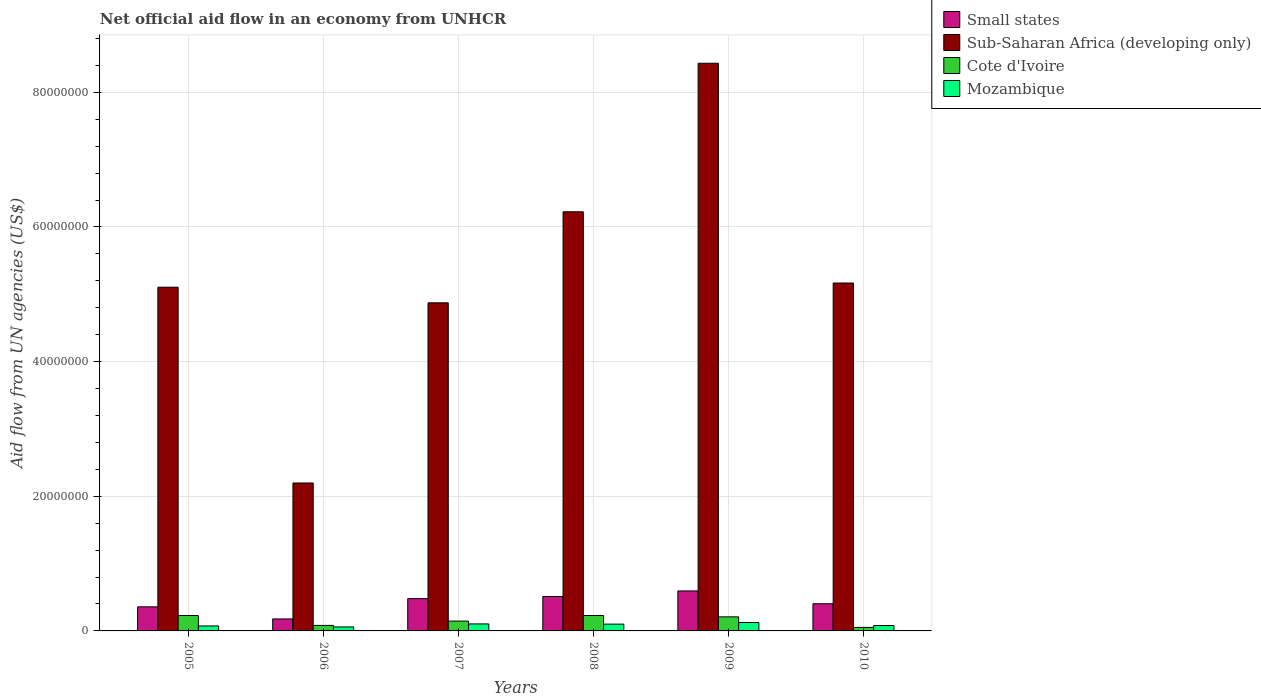How many different coloured bars are there?
Provide a succinct answer. 4. Are the number of bars per tick equal to the number of legend labels?
Make the answer very short. Yes. How many bars are there on the 1st tick from the right?
Provide a succinct answer. 4. What is the label of the 1st group of bars from the left?
Give a very brief answer. 2005. What is the net official aid flow in Small states in 2006?
Give a very brief answer. 1.78e+06. Across all years, what is the maximum net official aid flow in Mozambique?
Provide a short and direct response. 1.25e+06. Across all years, what is the minimum net official aid flow in Small states?
Your response must be concise. 1.78e+06. In which year was the net official aid flow in Cote d'Ivoire minimum?
Make the answer very short. 2010. What is the total net official aid flow in Mozambique in the graph?
Give a very brief answer. 5.43e+06. What is the difference between the net official aid flow in Small states in 2009 and that in 2010?
Your answer should be very brief. 1.90e+06. What is the difference between the net official aid flow in Mozambique in 2009 and the net official aid flow in Sub-Saharan Africa (developing only) in 2006?
Provide a succinct answer. -2.07e+07. What is the average net official aid flow in Sub-Saharan Africa (developing only) per year?
Keep it short and to the point. 5.33e+07. In the year 2007, what is the difference between the net official aid flow in Small states and net official aid flow in Cote d'Ivoire?
Your answer should be compact. 3.34e+06. In how many years, is the net official aid flow in Mozambique greater than 68000000 US$?
Provide a succinct answer. 0. Is the difference between the net official aid flow in Small states in 2006 and 2008 greater than the difference between the net official aid flow in Cote d'Ivoire in 2006 and 2008?
Make the answer very short. No. What is the difference between the highest and the second highest net official aid flow in Small states?
Give a very brief answer. 8.30e+05. What is the difference between the highest and the lowest net official aid flow in Small states?
Keep it short and to the point. 4.16e+06. Is it the case that in every year, the sum of the net official aid flow in Cote d'Ivoire and net official aid flow in Mozambique is greater than the sum of net official aid flow in Small states and net official aid flow in Sub-Saharan Africa (developing only)?
Make the answer very short. No. What does the 3rd bar from the left in 2005 represents?
Give a very brief answer. Cote d'Ivoire. What does the 4th bar from the right in 2009 represents?
Your response must be concise. Small states. Is it the case that in every year, the sum of the net official aid flow in Small states and net official aid flow in Sub-Saharan Africa (developing only) is greater than the net official aid flow in Cote d'Ivoire?
Your answer should be very brief. Yes. Does the graph contain any zero values?
Offer a terse response. No. Does the graph contain grids?
Offer a terse response. Yes. Where does the legend appear in the graph?
Give a very brief answer. Top right. How are the legend labels stacked?
Ensure brevity in your answer.  Vertical. What is the title of the graph?
Make the answer very short. Net official aid flow in an economy from UNHCR. Does "Other small states" appear as one of the legend labels in the graph?
Your answer should be very brief. No. What is the label or title of the X-axis?
Your answer should be compact. Years. What is the label or title of the Y-axis?
Provide a short and direct response. Aid flow from UN agencies (US$). What is the Aid flow from UN agencies (US$) of Small states in 2005?
Keep it short and to the point. 3.58e+06. What is the Aid flow from UN agencies (US$) in Sub-Saharan Africa (developing only) in 2005?
Provide a succinct answer. 5.10e+07. What is the Aid flow from UN agencies (US$) in Cote d'Ivoire in 2005?
Ensure brevity in your answer.  2.29e+06. What is the Aid flow from UN agencies (US$) of Mozambique in 2005?
Give a very brief answer. 7.40e+05. What is the Aid flow from UN agencies (US$) in Small states in 2006?
Offer a very short reply. 1.78e+06. What is the Aid flow from UN agencies (US$) of Sub-Saharan Africa (developing only) in 2006?
Make the answer very short. 2.20e+07. What is the Aid flow from UN agencies (US$) in Cote d'Ivoire in 2006?
Provide a short and direct response. 8.20e+05. What is the Aid flow from UN agencies (US$) of Mozambique in 2006?
Make the answer very short. 5.90e+05. What is the Aid flow from UN agencies (US$) of Small states in 2007?
Offer a very short reply. 4.80e+06. What is the Aid flow from UN agencies (US$) of Sub-Saharan Africa (developing only) in 2007?
Ensure brevity in your answer.  4.87e+07. What is the Aid flow from UN agencies (US$) of Cote d'Ivoire in 2007?
Give a very brief answer. 1.46e+06. What is the Aid flow from UN agencies (US$) of Mozambique in 2007?
Keep it short and to the point. 1.04e+06. What is the Aid flow from UN agencies (US$) of Small states in 2008?
Give a very brief answer. 5.11e+06. What is the Aid flow from UN agencies (US$) of Sub-Saharan Africa (developing only) in 2008?
Offer a terse response. 6.22e+07. What is the Aid flow from UN agencies (US$) of Cote d'Ivoire in 2008?
Provide a succinct answer. 2.29e+06. What is the Aid flow from UN agencies (US$) of Mozambique in 2008?
Offer a very short reply. 1.01e+06. What is the Aid flow from UN agencies (US$) in Small states in 2009?
Your response must be concise. 5.94e+06. What is the Aid flow from UN agencies (US$) of Sub-Saharan Africa (developing only) in 2009?
Offer a very short reply. 8.43e+07. What is the Aid flow from UN agencies (US$) in Cote d'Ivoire in 2009?
Your answer should be compact. 2.09e+06. What is the Aid flow from UN agencies (US$) in Mozambique in 2009?
Your response must be concise. 1.25e+06. What is the Aid flow from UN agencies (US$) of Small states in 2010?
Give a very brief answer. 4.04e+06. What is the Aid flow from UN agencies (US$) in Sub-Saharan Africa (developing only) in 2010?
Offer a very short reply. 5.17e+07. What is the Aid flow from UN agencies (US$) in Cote d'Ivoire in 2010?
Provide a succinct answer. 5.20e+05. Across all years, what is the maximum Aid flow from UN agencies (US$) in Small states?
Offer a very short reply. 5.94e+06. Across all years, what is the maximum Aid flow from UN agencies (US$) of Sub-Saharan Africa (developing only)?
Keep it short and to the point. 8.43e+07. Across all years, what is the maximum Aid flow from UN agencies (US$) of Cote d'Ivoire?
Provide a succinct answer. 2.29e+06. Across all years, what is the maximum Aid flow from UN agencies (US$) of Mozambique?
Ensure brevity in your answer.  1.25e+06. Across all years, what is the minimum Aid flow from UN agencies (US$) in Small states?
Your answer should be very brief. 1.78e+06. Across all years, what is the minimum Aid flow from UN agencies (US$) in Sub-Saharan Africa (developing only)?
Provide a succinct answer. 2.20e+07. Across all years, what is the minimum Aid flow from UN agencies (US$) of Cote d'Ivoire?
Offer a terse response. 5.20e+05. Across all years, what is the minimum Aid flow from UN agencies (US$) in Mozambique?
Ensure brevity in your answer.  5.90e+05. What is the total Aid flow from UN agencies (US$) of Small states in the graph?
Provide a succinct answer. 2.52e+07. What is the total Aid flow from UN agencies (US$) in Sub-Saharan Africa (developing only) in the graph?
Your response must be concise. 3.20e+08. What is the total Aid flow from UN agencies (US$) of Cote d'Ivoire in the graph?
Make the answer very short. 9.47e+06. What is the total Aid flow from UN agencies (US$) in Mozambique in the graph?
Ensure brevity in your answer.  5.43e+06. What is the difference between the Aid flow from UN agencies (US$) of Small states in 2005 and that in 2006?
Offer a terse response. 1.80e+06. What is the difference between the Aid flow from UN agencies (US$) in Sub-Saharan Africa (developing only) in 2005 and that in 2006?
Make the answer very short. 2.91e+07. What is the difference between the Aid flow from UN agencies (US$) in Cote d'Ivoire in 2005 and that in 2006?
Make the answer very short. 1.47e+06. What is the difference between the Aid flow from UN agencies (US$) in Mozambique in 2005 and that in 2006?
Offer a very short reply. 1.50e+05. What is the difference between the Aid flow from UN agencies (US$) of Small states in 2005 and that in 2007?
Keep it short and to the point. -1.22e+06. What is the difference between the Aid flow from UN agencies (US$) of Sub-Saharan Africa (developing only) in 2005 and that in 2007?
Make the answer very short. 2.32e+06. What is the difference between the Aid flow from UN agencies (US$) in Cote d'Ivoire in 2005 and that in 2007?
Your response must be concise. 8.30e+05. What is the difference between the Aid flow from UN agencies (US$) in Small states in 2005 and that in 2008?
Give a very brief answer. -1.53e+06. What is the difference between the Aid flow from UN agencies (US$) in Sub-Saharan Africa (developing only) in 2005 and that in 2008?
Ensure brevity in your answer.  -1.12e+07. What is the difference between the Aid flow from UN agencies (US$) in Small states in 2005 and that in 2009?
Your answer should be very brief. -2.36e+06. What is the difference between the Aid flow from UN agencies (US$) of Sub-Saharan Africa (developing only) in 2005 and that in 2009?
Provide a short and direct response. -3.33e+07. What is the difference between the Aid flow from UN agencies (US$) of Cote d'Ivoire in 2005 and that in 2009?
Provide a short and direct response. 2.00e+05. What is the difference between the Aid flow from UN agencies (US$) of Mozambique in 2005 and that in 2009?
Ensure brevity in your answer.  -5.10e+05. What is the difference between the Aid flow from UN agencies (US$) in Small states in 2005 and that in 2010?
Your answer should be very brief. -4.60e+05. What is the difference between the Aid flow from UN agencies (US$) of Sub-Saharan Africa (developing only) in 2005 and that in 2010?
Your answer should be very brief. -6.20e+05. What is the difference between the Aid flow from UN agencies (US$) in Cote d'Ivoire in 2005 and that in 2010?
Your response must be concise. 1.77e+06. What is the difference between the Aid flow from UN agencies (US$) of Small states in 2006 and that in 2007?
Your answer should be compact. -3.02e+06. What is the difference between the Aid flow from UN agencies (US$) in Sub-Saharan Africa (developing only) in 2006 and that in 2007?
Your answer should be very brief. -2.68e+07. What is the difference between the Aid flow from UN agencies (US$) in Cote d'Ivoire in 2006 and that in 2007?
Your response must be concise. -6.40e+05. What is the difference between the Aid flow from UN agencies (US$) of Mozambique in 2006 and that in 2007?
Your answer should be compact. -4.50e+05. What is the difference between the Aid flow from UN agencies (US$) in Small states in 2006 and that in 2008?
Make the answer very short. -3.33e+06. What is the difference between the Aid flow from UN agencies (US$) of Sub-Saharan Africa (developing only) in 2006 and that in 2008?
Offer a very short reply. -4.03e+07. What is the difference between the Aid flow from UN agencies (US$) of Cote d'Ivoire in 2006 and that in 2008?
Offer a terse response. -1.47e+06. What is the difference between the Aid flow from UN agencies (US$) in Mozambique in 2006 and that in 2008?
Keep it short and to the point. -4.20e+05. What is the difference between the Aid flow from UN agencies (US$) of Small states in 2006 and that in 2009?
Your answer should be compact. -4.16e+06. What is the difference between the Aid flow from UN agencies (US$) of Sub-Saharan Africa (developing only) in 2006 and that in 2009?
Keep it short and to the point. -6.23e+07. What is the difference between the Aid flow from UN agencies (US$) of Cote d'Ivoire in 2006 and that in 2009?
Make the answer very short. -1.27e+06. What is the difference between the Aid flow from UN agencies (US$) in Mozambique in 2006 and that in 2009?
Make the answer very short. -6.60e+05. What is the difference between the Aid flow from UN agencies (US$) in Small states in 2006 and that in 2010?
Offer a terse response. -2.26e+06. What is the difference between the Aid flow from UN agencies (US$) of Sub-Saharan Africa (developing only) in 2006 and that in 2010?
Keep it short and to the point. -2.97e+07. What is the difference between the Aid flow from UN agencies (US$) in Small states in 2007 and that in 2008?
Give a very brief answer. -3.10e+05. What is the difference between the Aid flow from UN agencies (US$) of Sub-Saharan Africa (developing only) in 2007 and that in 2008?
Your answer should be compact. -1.35e+07. What is the difference between the Aid flow from UN agencies (US$) of Cote d'Ivoire in 2007 and that in 2008?
Keep it short and to the point. -8.30e+05. What is the difference between the Aid flow from UN agencies (US$) in Small states in 2007 and that in 2009?
Ensure brevity in your answer.  -1.14e+06. What is the difference between the Aid flow from UN agencies (US$) of Sub-Saharan Africa (developing only) in 2007 and that in 2009?
Provide a succinct answer. -3.56e+07. What is the difference between the Aid flow from UN agencies (US$) of Cote d'Ivoire in 2007 and that in 2009?
Keep it short and to the point. -6.30e+05. What is the difference between the Aid flow from UN agencies (US$) of Small states in 2007 and that in 2010?
Offer a very short reply. 7.60e+05. What is the difference between the Aid flow from UN agencies (US$) of Sub-Saharan Africa (developing only) in 2007 and that in 2010?
Make the answer very short. -2.94e+06. What is the difference between the Aid flow from UN agencies (US$) in Cote d'Ivoire in 2007 and that in 2010?
Provide a short and direct response. 9.40e+05. What is the difference between the Aid flow from UN agencies (US$) of Mozambique in 2007 and that in 2010?
Offer a very short reply. 2.40e+05. What is the difference between the Aid flow from UN agencies (US$) of Small states in 2008 and that in 2009?
Keep it short and to the point. -8.30e+05. What is the difference between the Aid flow from UN agencies (US$) of Sub-Saharan Africa (developing only) in 2008 and that in 2009?
Provide a succinct answer. -2.21e+07. What is the difference between the Aid flow from UN agencies (US$) in Cote d'Ivoire in 2008 and that in 2009?
Make the answer very short. 2.00e+05. What is the difference between the Aid flow from UN agencies (US$) in Mozambique in 2008 and that in 2009?
Your answer should be compact. -2.40e+05. What is the difference between the Aid flow from UN agencies (US$) in Small states in 2008 and that in 2010?
Your answer should be very brief. 1.07e+06. What is the difference between the Aid flow from UN agencies (US$) in Sub-Saharan Africa (developing only) in 2008 and that in 2010?
Make the answer very short. 1.06e+07. What is the difference between the Aid flow from UN agencies (US$) in Cote d'Ivoire in 2008 and that in 2010?
Make the answer very short. 1.77e+06. What is the difference between the Aid flow from UN agencies (US$) in Mozambique in 2008 and that in 2010?
Your response must be concise. 2.10e+05. What is the difference between the Aid flow from UN agencies (US$) in Small states in 2009 and that in 2010?
Your answer should be very brief. 1.90e+06. What is the difference between the Aid flow from UN agencies (US$) in Sub-Saharan Africa (developing only) in 2009 and that in 2010?
Ensure brevity in your answer.  3.26e+07. What is the difference between the Aid flow from UN agencies (US$) of Cote d'Ivoire in 2009 and that in 2010?
Ensure brevity in your answer.  1.57e+06. What is the difference between the Aid flow from UN agencies (US$) of Small states in 2005 and the Aid flow from UN agencies (US$) of Sub-Saharan Africa (developing only) in 2006?
Offer a very short reply. -1.84e+07. What is the difference between the Aid flow from UN agencies (US$) in Small states in 2005 and the Aid flow from UN agencies (US$) in Cote d'Ivoire in 2006?
Your response must be concise. 2.76e+06. What is the difference between the Aid flow from UN agencies (US$) of Small states in 2005 and the Aid flow from UN agencies (US$) of Mozambique in 2006?
Provide a succinct answer. 2.99e+06. What is the difference between the Aid flow from UN agencies (US$) of Sub-Saharan Africa (developing only) in 2005 and the Aid flow from UN agencies (US$) of Cote d'Ivoire in 2006?
Offer a very short reply. 5.02e+07. What is the difference between the Aid flow from UN agencies (US$) in Sub-Saharan Africa (developing only) in 2005 and the Aid flow from UN agencies (US$) in Mozambique in 2006?
Keep it short and to the point. 5.05e+07. What is the difference between the Aid flow from UN agencies (US$) of Cote d'Ivoire in 2005 and the Aid flow from UN agencies (US$) of Mozambique in 2006?
Offer a very short reply. 1.70e+06. What is the difference between the Aid flow from UN agencies (US$) of Small states in 2005 and the Aid flow from UN agencies (US$) of Sub-Saharan Africa (developing only) in 2007?
Make the answer very short. -4.52e+07. What is the difference between the Aid flow from UN agencies (US$) in Small states in 2005 and the Aid flow from UN agencies (US$) in Cote d'Ivoire in 2007?
Offer a very short reply. 2.12e+06. What is the difference between the Aid flow from UN agencies (US$) of Small states in 2005 and the Aid flow from UN agencies (US$) of Mozambique in 2007?
Provide a succinct answer. 2.54e+06. What is the difference between the Aid flow from UN agencies (US$) of Sub-Saharan Africa (developing only) in 2005 and the Aid flow from UN agencies (US$) of Cote d'Ivoire in 2007?
Give a very brief answer. 4.96e+07. What is the difference between the Aid flow from UN agencies (US$) of Sub-Saharan Africa (developing only) in 2005 and the Aid flow from UN agencies (US$) of Mozambique in 2007?
Give a very brief answer. 5.00e+07. What is the difference between the Aid flow from UN agencies (US$) of Cote d'Ivoire in 2005 and the Aid flow from UN agencies (US$) of Mozambique in 2007?
Offer a very short reply. 1.25e+06. What is the difference between the Aid flow from UN agencies (US$) in Small states in 2005 and the Aid flow from UN agencies (US$) in Sub-Saharan Africa (developing only) in 2008?
Your answer should be compact. -5.87e+07. What is the difference between the Aid flow from UN agencies (US$) of Small states in 2005 and the Aid flow from UN agencies (US$) of Cote d'Ivoire in 2008?
Your answer should be very brief. 1.29e+06. What is the difference between the Aid flow from UN agencies (US$) of Small states in 2005 and the Aid flow from UN agencies (US$) of Mozambique in 2008?
Make the answer very short. 2.57e+06. What is the difference between the Aid flow from UN agencies (US$) of Sub-Saharan Africa (developing only) in 2005 and the Aid flow from UN agencies (US$) of Cote d'Ivoire in 2008?
Give a very brief answer. 4.88e+07. What is the difference between the Aid flow from UN agencies (US$) of Sub-Saharan Africa (developing only) in 2005 and the Aid flow from UN agencies (US$) of Mozambique in 2008?
Provide a succinct answer. 5.00e+07. What is the difference between the Aid flow from UN agencies (US$) of Cote d'Ivoire in 2005 and the Aid flow from UN agencies (US$) of Mozambique in 2008?
Your answer should be compact. 1.28e+06. What is the difference between the Aid flow from UN agencies (US$) in Small states in 2005 and the Aid flow from UN agencies (US$) in Sub-Saharan Africa (developing only) in 2009?
Your answer should be very brief. -8.07e+07. What is the difference between the Aid flow from UN agencies (US$) of Small states in 2005 and the Aid flow from UN agencies (US$) of Cote d'Ivoire in 2009?
Provide a succinct answer. 1.49e+06. What is the difference between the Aid flow from UN agencies (US$) in Small states in 2005 and the Aid flow from UN agencies (US$) in Mozambique in 2009?
Provide a succinct answer. 2.33e+06. What is the difference between the Aid flow from UN agencies (US$) of Sub-Saharan Africa (developing only) in 2005 and the Aid flow from UN agencies (US$) of Cote d'Ivoire in 2009?
Your answer should be compact. 4.90e+07. What is the difference between the Aid flow from UN agencies (US$) of Sub-Saharan Africa (developing only) in 2005 and the Aid flow from UN agencies (US$) of Mozambique in 2009?
Make the answer very short. 4.98e+07. What is the difference between the Aid flow from UN agencies (US$) in Cote d'Ivoire in 2005 and the Aid flow from UN agencies (US$) in Mozambique in 2009?
Give a very brief answer. 1.04e+06. What is the difference between the Aid flow from UN agencies (US$) of Small states in 2005 and the Aid flow from UN agencies (US$) of Sub-Saharan Africa (developing only) in 2010?
Provide a short and direct response. -4.81e+07. What is the difference between the Aid flow from UN agencies (US$) of Small states in 2005 and the Aid flow from UN agencies (US$) of Cote d'Ivoire in 2010?
Provide a succinct answer. 3.06e+06. What is the difference between the Aid flow from UN agencies (US$) of Small states in 2005 and the Aid flow from UN agencies (US$) of Mozambique in 2010?
Offer a terse response. 2.78e+06. What is the difference between the Aid flow from UN agencies (US$) of Sub-Saharan Africa (developing only) in 2005 and the Aid flow from UN agencies (US$) of Cote d'Ivoire in 2010?
Provide a short and direct response. 5.05e+07. What is the difference between the Aid flow from UN agencies (US$) in Sub-Saharan Africa (developing only) in 2005 and the Aid flow from UN agencies (US$) in Mozambique in 2010?
Your answer should be very brief. 5.02e+07. What is the difference between the Aid flow from UN agencies (US$) in Cote d'Ivoire in 2005 and the Aid flow from UN agencies (US$) in Mozambique in 2010?
Provide a short and direct response. 1.49e+06. What is the difference between the Aid flow from UN agencies (US$) of Small states in 2006 and the Aid flow from UN agencies (US$) of Sub-Saharan Africa (developing only) in 2007?
Provide a short and direct response. -4.70e+07. What is the difference between the Aid flow from UN agencies (US$) in Small states in 2006 and the Aid flow from UN agencies (US$) in Mozambique in 2007?
Make the answer very short. 7.40e+05. What is the difference between the Aid flow from UN agencies (US$) in Sub-Saharan Africa (developing only) in 2006 and the Aid flow from UN agencies (US$) in Cote d'Ivoire in 2007?
Offer a very short reply. 2.05e+07. What is the difference between the Aid flow from UN agencies (US$) of Sub-Saharan Africa (developing only) in 2006 and the Aid flow from UN agencies (US$) of Mozambique in 2007?
Provide a short and direct response. 2.09e+07. What is the difference between the Aid flow from UN agencies (US$) in Cote d'Ivoire in 2006 and the Aid flow from UN agencies (US$) in Mozambique in 2007?
Your answer should be compact. -2.20e+05. What is the difference between the Aid flow from UN agencies (US$) of Small states in 2006 and the Aid flow from UN agencies (US$) of Sub-Saharan Africa (developing only) in 2008?
Ensure brevity in your answer.  -6.05e+07. What is the difference between the Aid flow from UN agencies (US$) of Small states in 2006 and the Aid flow from UN agencies (US$) of Cote d'Ivoire in 2008?
Offer a terse response. -5.10e+05. What is the difference between the Aid flow from UN agencies (US$) of Small states in 2006 and the Aid flow from UN agencies (US$) of Mozambique in 2008?
Keep it short and to the point. 7.70e+05. What is the difference between the Aid flow from UN agencies (US$) of Sub-Saharan Africa (developing only) in 2006 and the Aid flow from UN agencies (US$) of Cote d'Ivoire in 2008?
Provide a short and direct response. 1.97e+07. What is the difference between the Aid flow from UN agencies (US$) in Sub-Saharan Africa (developing only) in 2006 and the Aid flow from UN agencies (US$) in Mozambique in 2008?
Keep it short and to the point. 2.10e+07. What is the difference between the Aid flow from UN agencies (US$) of Cote d'Ivoire in 2006 and the Aid flow from UN agencies (US$) of Mozambique in 2008?
Your answer should be compact. -1.90e+05. What is the difference between the Aid flow from UN agencies (US$) of Small states in 2006 and the Aid flow from UN agencies (US$) of Sub-Saharan Africa (developing only) in 2009?
Your response must be concise. -8.25e+07. What is the difference between the Aid flow from UN agencies (US$) in Small states in 2006 and the Aid flow from UN agencies (US$) in Cote d'Ivoire in 2009?
Provide a short and direct response. -3.10e+05. What is the difference between the Aid flow from UN agencies (US$) in Small states in 2006 and the Aid flow from UN agencies (US$) in Mozambique in 2009?
Your answer should be compact. 5.30e+05. What is the difference between the Aid flow from UN agencies (US$) of Sub-Saharan Africa (developing only) in 2006 and the Aid flow from UN agencies (US$) of Cote d'Ivoire in 2009?
Ensure brevity in your answer.  1.99e+07. What is the difference between the Aid flow from UN agencies (US$) of Sub-Saharan Africa (developing only) in 2006 and the Aid flow from UN agencies (US$) of Mozambique in 2009?
Make the answer very short. 2.07e+07. What is the difference between the Aid flow from UN agencies (US$) of Cote d'Ivoire in 2006 and the Aid flow from UN agencies (US$) of Mozambique in 2009?
Provide a short and direct response. -4.30e+05. What is the difference between the Aid flow from UN agencies (US$) in Small states in 2006 and the Aid flow from UN agencies (US$) in Sub-Saharan Africa (developing only) in 2010?
Provide a succinct answer. -4.99e+07. What is the difference between the Aid flow from UN agencies (US$) of Small states in 2006 and the Aid flow from UN agencies (US$) of Cote d'Ivoire in 2010?
Provide a succinct answer. 1.26e+06. What is the difference between the Aid flow from UN agencies (US$) of Small states in 2006 and the Aid flow from UN agencies (US$) of Mozambique in 2010?
Your response must be concise. 9.80e+05. What is the difference between the Aid flow from UN agencies (US$) in Sub-Saharan Africa (developing only) in 2006 and the Aid flow from UN agencies (US$) in Cote d'Ivoire in 2010?
Your answer should be very brief. 2.14e+07. What is the difference between the Aid flow from UN agencies (US$) in Sub-Saharan Africa (developing only) in 2006 and the Aid flow from UN agencies (US$) in Mozambique in 2010?
Offer a very short reply. 2.12e+07. What is the difference between the Aid flow from UN agencies (US$) in Small states in 2007 and the Aid flow from UN agencies (US$) in Sub-Saharan Africa (developing only) in 2008?
Provide a succinct answer. -5.74e+07. What is the difference between the Aid flow from UN agencies (US$) in Small states in 2007 and the Aid flow from UN agencies (US$) in Cote d'Ivoire in 2008?
Your response must be concise. 2.51e+06. What is the difference between the Aid flow from UN agencies (US$) in Small states in 2007 and the Aid flow from UN agencies (US$) in Mozambique in 2008?
Provide a short and direct response. 3.79e+06. What is the difference between the Aid flow from UN agencies (US$) of Sub-Saharan Africa (developing only) in 2007 and the Aid flow from UN agencies (US$) of Cote d'Ivoire in 2008?
Provide a short and direct response. 4.64e+07. What is the difference between the Aid flow from UN agencies (US$) of Sub-Saharan Africa (developing only) in 2007 and the Aid flow from UN agencies (US$) of Mozambique in 2008?
Ensure brevity in your answer.  4.77e+07. What is the difference between the Aid flow from UN agencies (US$) of Cote d'Ivoire in 2007 and the Aid flow from UN agencies (US$) of Mozambique in 2008?
Offer a very short reply. 4.50e+05. What is the difference between the Aid flow from UN agencies (US$) of Small states in 2007 and the Aid flow from UN agencies (US$) of Sub-Saharan Africa (developing only) in 2009?
Make the answer very short. -7.95e+07. What is the difference between the Aid flow from UN agencies (US$) of Small states in 2007 and the Aid flow from UN agencies (US$) of Cote d'Ivoire in 2009?
Make the answer very short. 2.71e+06. What is the difference between the Aid flow from UN agencies (US$) in Small states in 2007 and the Aid flow from UN agencies (US$) in Mozambique in 2009?
Offer a very short reply. 3.55e+06. What is the difference between the Aid flow from UN agencies (US$) of Sub-Saharan Africa (developing only) in 2007 and the Aid flow from UN agencies (US$) of Cote d'Ivoire in 2009?
Provide a short and direct response. 4.66e+07. What is the difference between the Aid flow from UN agencies (US$) in Sub-Saharan Africa (developing only) in 2007 and the Aid flow from UN agencies (US$) in Mozambique in 2009?
Make the answer very short. 4.75e+07. What is the difference between the Aid flow from UN agencies (US$) in Small states in 2007 and the Aid flow from UN agencies (US$) in Sub-Saharan Africa (developing only) in 2010?
Give a very brief answer. -4.69e+07. What is the difference between the Aid flow from UN agencies (US$) of Small states in 2007 and the Aid flow from UN agencies (US$) of Cote d'Ivoire in 2010?
Give a very brief answer. 4.28e+06. What is the difference between the Aid flow from UN agencies (US$) of Sub-Saharan Africa (developing only) in 2007 and the Aid flow from UN agencies (US$) of Cote d'Ivoire in 2010?
Give a very brief answer. 4.82e+07. What is the difference between the Aid flow from UN agencies (US$) in Sub-Saharan Africa (developing only) in 2007 and the Aid flow from UN agencies (US$) in Mozambique in 2010?
Your answer should be compact. 4.79e+07. What is the difference between the Aid flow from UN agencies (US$) of Cote d'Ivoire in 2007 and the Aid flow from UN agencies (US$) of Mozambique in 2010?
Provide a short and direct response. 6.60e+05. What is the difference between the Aid flow from UN agencies (US$) in Small states in 2008 and the Aid flow from UN agencies (US$) in Sub-Saharan Africa (developing only) in 2009?
Provide a succinct answer. -7.92e+07. What is the difference between the Aid flow from UN agencies (US$) of Small states in 2008 and the Aid flow from UN agencies (US$) of Cote d'Ivoire in 2009?
Offer a very short reply. 3.02e+06. What is the difference between the Aid flow from UN agencies (US$) of Small states in 2008 and the Aid flow from UN agencies (US$) of Mozambique in 2009?
Ensure brevity in your answer.  3.86e+06. What is the difference between the Aid flow from UN agencies (US$) of Sub-Saharan Africa (developing only) in 2008 and the Aid flow from UN agencies (US$) of Cote d'Ivoire in 2009?
Provide a succinct answer. 6.02e+07. What is the difference between the Aid flow from UN agencies (US$) of Sub-Saharan Africa (developing only) in 2008 and the Aid flow from UN agencies (US$) of Mozambique in 2009?
Keep it short and to the point. 6.10e+07. What is the difference between the Aid flow from UN agencies (US$) in Cote d'Ivoire in 2008 and the Aid flow from UN agencies (US$) in Mozambique in 2009?
Your answer should be compact. 1.04e+06. What is the difference between the Aid flow from UN agencies (US$) in Small states in 2008 and the Aid flow from UN agencies (US$) in Sub-Saharan Africa (developing only) in 2010?
Your answer should be very brief. -4.66e+07. What is the difference between the Aid flow from UN agencies (US$) of Small states in 2008 and the Aid flow from UN agencies (US$) of Cote d'Ivoire in 2010?
Ensure brevity in your answer.  4.59e+06. What is the difference between the Aid flow from UN agencies (US$) of Small states in 2008 and the Aid flow from UN agencies (US$) of Mozambique in 2010?
Keep it short and to the point. 4.31e+06. What is the difference between the Aid flow from UN agencies (US$) in Sub-Saharan Africa (developing only) in 2008 and the Aid flow from UN agencies (US$) in Cote d'Ivoire in 2010?
Provide a succinct answer. 6.17e+07. What is the difference between the Aid flow from UN agencies (US$) of Sub-Saharan Africa (developing only) in 2008 and the Aid flow from UN agencies (US$) of Mozambique in 2010?
Ensure brevity in your answer.  6.14e+07. What is the difference between the Aid flow from UN agencies (US$) of Cote d'Ivoire in 2008 and the Aid flow from UN agencies (US$) of Mozambique in 2010?
Provide a succinct answer. 1.49e+06. What is the difference between the Aid flow from UN agencies (US$) of Small states in 2009 and the Aid flow from UN agencies (US$) of Sub-Saharan Africa (developing only) in 2010?
Your answer should be compact. -4.57e+07. What is the difference between the Aid flow from UN agencies (US$) of Small states in 2009 and the Aid flow from UN agencies (US$) of Cote d'Ivoire in 2010?
Offer a very short reply. 5.42e+06. What is the difference between the Aid flow from UN agencies (US$) in Small states in 2009 and the Aid flow from UN agencies (US$) in Mozambique in 2010?
Offer a terse response. 5.14e+06. What is the difference between the Aid flow from UN agencies (US$) of Sub-Saharan Africa (developing only) in 2009 and the Aid flow from UN agencies (US$) of Cote d'Ivoire in 2010?
Ensure brevity in your answer.  8.38e+07. What is the difference between the Aid flow from UN agencies (US$) in Sub-Saharan Africa (developing only) in 2009 and the Aid flow from UN agencies (US$) in Mozambique in 2010?
Provide a succinct answer. 8.35e+07. What is the difference between the Aid flow from UN agencies (US$) of Cote d'Ivoire in 2009 and the Aid flow from UN agencies (US$) of Mozambique in 2010?
Give a very brief answer. 1.29e+06. What is the average Aid flow from UN agencies (US$) in Small states per year?
Your answer should be very brief. 4.21e+06. What is the average Aid flow from UN agencies (US$) of Sub-Saharan Africa (developing only) per year?
Ensure brevity in your answer.  5.33e+07. What is the average Aid flow from UN agencies (US$) of Cote d'Ivoire per year?
Provide a short and direct response. 1.58e+06. What is the average Aid flow from UN agencies (US$) in Mozambique per year?
Your answer should be compact. 9.05e+05. In the year 2005, what is the difference between the Aid flow from UN agencies (US$) in Small states and Aid flow from UN agencies (US$) in Sub-Saharan Africa (developing only)?
Your answer should be very brief. -4.75e+07. In the year 2005, what is the difference between the Aid flow from UN agencies (US$) in Small states and Aid flow from UN agencies (US$) in Cote d'Ivoire?
Provide a succinct answer. 1.29e+06. In the year 2005, what is the difference between the Aid flow from UN agencies (US$) of Small states and Aid flow from UN agencies (US$) of Mozambique?
Give a very brief answer. 2.84e+06. In the year 2005, what is the difference between the Aid flow from UN agencies (US$) in Sub-Saharan Africa (developing only) and Aid flow from UN agencies (US$) in Cote d'Ivoire?
Make the answer very short. 4.88e+07. In the year 2005, what is the difference between the Aid flow from UN agencies (US$) in Sub-Saharan Africa (developing only) and Aid flow from UN agencies (US$) in Mozambique?
Offer a terse response. 5.03e+07. In the year 2005, what is the difference between the Aid flow from UN agencies (US$) in Cote d'Ivoire and Aid flow from UN agencies (US$) in Mozambique?
Provide a short and direct response. 1.55e+06. In the year 2006, what is the difference between the Aid flow from UN agencies (US$) in Small states and Aid flow from UN agencies (US$) in Sub-Saharan Africa (developing only)?
Your response must be concise. -2.02e+07. In the year 2006, what is the difference between the Aid flow from UN agencies (US$) in Small states and Aid flow from UN agencies (US$) in Cote d'Ivoire?
Your answer should be compact. 9.60e+05. In the year 2006, what is the difference between the Aid flow from UN agencies (US$) in Small states and Aid flow from UN agencies (US$) in Mozambique?
Your answer should be very brief. 1.19e+06. In the year 2006, what is the difference between the Aid flow from UN agencies (US$) in Sub-Saharan Africa (developing only) and Aid flow from UN agencies (US$) in Cote d'Ivoire?
Your answer should be very brief. 2.12e+07. In the year 2006, what is the difference between the Aid flow from UN agencies (US$) of Sub-Saharan Africa (developing only) and Aid flow from UN agencies (US$) of Mozambique?
Provide a short and direct response. 2.14e+07. In the year 2006, what is the difference between the Aid flow from UN agencies (US$) in Cote d'Ivoire and Aid flow from UN agencies (US$) in Mozambique?
Make the answer very short. 2.30e+05. In the year 2007, what is the difference between the Aid flow from UN agencies (US$) in Small states and Aid flow from UN agencies (US$) in Sub-Saharan Africa (developing only)?
Your answer should be very brief. -4.39e+07. In the year 2007, what is the difference between the Aid flow from UN agencies (US$) in Small states and Aid flow from UN agencies (US$) in Cote d'Ivoire?
Offer a terse response. 3.34e+06. In the year 2007, what is the difference between the Aid flow from UN agencies (US$) in Small states and Aid flow from UN agencies (US$) in Mozambique?
Your response must be concise. 3.76e+06. In the year 2007, what is the difference between the Aid flow from UN agencies (US$) in Sub-Saharan Africa (developing only) and Aid flow from UN agencies (US$) in Cote d'Ivoire?
Your answer should be compact. 4.73e+07. In the year 2007, what is the difference between the Aid flow from UN agencies (US$) of Sub-Saharan Africa (developing only) and Aid flow from UN agencies (US$) of Mozambique?
Your response must be concise. 4.77e+07. In the year 2007, what is the difference between the Aid flow from UN agencies (US$) in Cote d'Ivoire and Aid flow from UN agencies (US$) in Mozambique?
Keep it short and to the point. 4.20e+05. In the year 2008, what is the difference between the Aid flow from UN agencies (US$) of Small states and Aid flow from UN agencies (US$) of Sub-Saharan Africa (developing only)?
Give a very brief answer. -5.71e+07. In the year 2008, what is the difference between the Aid flow from UN agencies (US$) in Small states and Aid flow from UN agencies (US$) in Cote d'Ivoire?
Keep it short and to the point. 2.82e+06. In the year 2008, what is the difference between the Aid flow from UN agencies (US$) of Small states and Aid flow from UN agencies (US$) of Mozambique?
Provide a short and direct response. 4.10e+06. In the year 2008, what is the difference between the Aid flow from UN agencies (US$) in Sub-Saharan Africa (developing only) and Aid flow from UN agencies (US$) in Cote d'Ivoire?
Your response must be concise. 6.00e+07. In the year 2008, what is the difference between the Aid flow from UN agencies (US$) of Sub-Saharan Africa (developing only) and Aid flow from UN agencies (US$) of Mozambique?
Provide a short and direct response. 6.12e+07. In the year 2008, what is the difference between the Aid flow from UN agencies (US$) of Cote d'Ivoire and Aid flow from UN agencies (US$) of Mozambique?
Offer a very short reply. 1.28e+06. In the year 2009, what is the difference between the Aid flow from UN agencies (US$) of Small states and Aid flow from UN agencies (US$) of Sub-Saharan Africa (developing only)?
Provide a short and direct response. -7.84e+07. In the year 2009, what is the difference between the Aid flow from UN agencies (US$) of Small states and Aid flow from UN agencies (US$) of Cote d'Ivoire?
Offer a very short reply. 3.85e+06. In the year 2009, what is the difference between the Aid flow from UN agencies (US$) of Small states and Aid flow from UN agencies (US$) of Mozambique?
Give a very brief answer. 4.69e+06. In the year 2009, what is the difference between the Aid flow from UN agencies (US$) in Sub-Saharan Africa (developing only) and Aid flow from UN agencies (US$) in Cote d'Ivoire?
Your answer should be compact. 8.22e+07. In the year 2009, what is the difference between the Aid flow from UN agencies (US$) of Sub-Saharan Africa (developing only) and Aid flow from UN agencies (US$) of Mozambique?
Provide a short and direct response. 8.31e+07. In the year 2009, what is the difference between the Aid flow from UN agencies (US$) of Cote d'Ivoire and Aid flow from UN agencies (US$) of Mozambique?
Make the answer very short. 8.40e+05. In the year 2010, what is the difference between the Aid flow from UN agencies (US$) in Small states and Aid flow from UN agencies (US$) in Sub-Saharan Africa (developing only)?
Give a very brief answer. -4.76e+07. In the year 2010, what is the difference between the Aid flow from UN agencies (US$) in Small states and Aid flow from UN agencies (US$) in Cote d'Ivoire?
Provide a succinct answer. 3.52e+06. In the year 2010, what is the difference between the Aid flow from UN agencies (US$) in Small states and Aid flow from UN agencies (US$) in Mozambique?
Provide a succinct answer. 3.24e+06. In the year 2010, what is the difference between the Aid flow from UN agencies (US$) of Sub-Saharan Africa (developing only) and Aid flow from UN agencies (US$) of Cote d'Ivoire?
Offer a very short reply. 5.12e+07. In the year 2010, what is the difference between the Aid flow from UN agencies (US$) of Sub-Saharan Africa (developing only) and Aid flow from UN agencies (US$) of Mozambique?
Give a very brief answer. 5.09e+07. In the year 2010, what is the difference between the Aid flow from UN agencies (US$) of Cote d'Ivoire and Aid flow from UN agencies (US$) of Mozambique?
Offer a terse response. -2.80e+05. What is the ratio of the Aid flow from UN agencies (US$) of Small states in 2005 to that in 2006?
Your answer should be compact. 2.01. What is the ratio of the Aid flow from UN agencies (US$) of Sub-Saharan Africa (developing only) in 2005 to that in 2006?
Offer a very short reply. 2.32. What is the ratio of the Aid flow from UN agencies (US$) of Cote d'Ivoire in 2005 to that in 2006?
Provide a succinct answer. 2.79. What is the ratio of the Aid flow from UN agencies (US$) of Mozambique in 2005 to that in 2006?
Your response must be concise. 1.25. What is the ratio of the Aid flow from UN agencies (US$) of Small states in 2005 to that in 2007?
Make the answer very short. 0.75. What is the ratio of the Aid flow from UN agencies (US$) of Sub-Saharan Africa (developing only) in 2005 to that in 2007?
Offer a very short reply. 1.05. What is the ratio of the Aid flow from UN agencies (US$) in Cote d'Ivoire in 2005 to that in 2007?
Your answer should be compact. 1.57. What is the ratio of the Aid flow from UN agencies (US$) of Mozambique in 2005 to that in 2007?
Your answer should be compact. 0.71. What is the ratio of the Aid flow from UN agencies (US$) in Small states in 2005 to that in 2008?
Your answer should be compact. 0.7. What is the ratio of the Aid flow from UN agencies (US$) in Sub-Saharan Africa (developing only) in 2005 to that in 2008?
Your answer should be very brief. 0.82. What is the ratio of the Aid flow from UN agencies (US$) in Mozambique in 2005 to that in 2008?
Offer a very short reply. 0.73. What is the ratio of the Aid flow from UN agencies (US$) of Small states in 2005 to that in 2009?
Make the answer very short. 0.6. What is the ratio of the Aid flow from UN agencies (US$) in Sub-Saharan Africa (developing only) in 2005 to that in 2009?
Your response must be concise. 0.61. What is the ratio of the Aid flow from UN agencies (US$) of Cote d'Ivoire in 2005 to that in 2009?
Your answer should be very brief. 1.1. What is the ratio of the Aid flow from UN agencies (US$) of Mozambique in 2005 to that in 2009?
Provide a succinct answer. 0.59. What is the ratio of the Aid flow from UN agencies (US$) in Small states in 2005 to that in 2010?
Provide a succinct answer. 0.89. What is the ratio of the Aid flow from UN agencies (US$) of Sub-Saharan Africa (developing only) in 2005 to that in 2010?
Offer a terse response. 0.99. What is the ratio of the Aid flow from UN agencies (US$) of Cote d'Ivoire in 2005 to that in 2010?
Ensure brevity in your answer.  4.4. What is the ratio of the Aid flow from UN agencies (US$) in Mozambique in 2005 to that in 2010?
Provide a succinct answer. 0.93. What is the ratio of the Aid flow from UN agencies (US$) in Small states in 2006 to that in 2007?
Make the answer very short. 0.37. What is the ratio of the Aid flow from UN agencies (US$) in Sub-Saharan Africa (developing only) in 2006 to that in 2007?
Your answer should be compact. 0.45. What is the ratio of the Aid flow from UN agencies (US$) in Cote d'Ivoire in 2006 to that in 2007?
Offer a terse response. 0.56. What is the ratio of the Aid flow from UN agencies (US$) of Mozambique in 2006 to that in 2007?
Give a very brief answer. 0.57. What is the ratio of the Aid flow from UN agencies (US$) in Small states in 2006 to that in 2008?
Your response must be concise. 0.35. What is the ratio of the Aid flow from UN agencies (US$) in Sub-Saharan Africa (developing only) in 2006 to that in 2008?
Keep it short and to the point. 0.35. What is the ratio of the Aid flow from UN agencies (US$) of Cote d'Ivoire in 2006 to that in 2008?
Provide a succinct answer. 0.36. What is the ratio of the Aid flow from UN agencies (US$) in Mozambique in 2006 to that in 2008?
Make the answer very short. 0.58. What is the ratio of the Aid flow from UN agencies (US$) of Small states in 2006 to that in 2009?
Provide a short and direct response. 0.3. What is the ratio of the Aid flow from UN agencies (US$) of Sub-Saharan Africa (developing only) in 2006 to that in 2009?
Make the answer very short. 0.26. What is the ratio of the Aid flow from UN agencies (US$) of Cote d'Ivoire in 2006 to that in 2009?
Make the answer very short. 0.39. What is the ratio of the Aid flow from UN agencies (US$) of Mozambique in 2006 to that in 2009?
Your response must be concise. 0.47. What is the ratio of the Aid flow from UN agencies (US$) in Small states in 2006 to that in 2010?
Ensure brevity in your answer.  0.44. What is the ratio of the Aid flow from UN agencies (US$) in Sub-Saharan Africa (developing only) in 2006 to that in 2010?
Provide a short and direct response. 0.43. What is the ratio of the Aid flow from UN agencies (US$) of Cote d'Ivoire in 2006 to that in 2010?
Provide a succinct answer. 1.58. What is the ratio of the Aid flow from UN agencies (US$) of Mozambique in 2006 to that in 2010?
Keep it short and to the point. 0.74. What is the ratio of the Aid flow from UN agencies (US$) of Small states in 2007 to that in 2008?
Your response must be concise. 0.94. What is the ratio of the Aid flow from UN agencies (US$) in Sub-Saharan Africa (developing only) in 2007 to that in 2008?
Offer a very short reply. 0.78. What is the ratio of the Aid flow from UN agencies (US$) in Cote d'Ivoire in 2007 to that in 2008?
Give a very brief answer. 0.64. What is the ratio of the Aid flow from UN agencies (US$) of Mozambique in 2007 to that in 2008?
Keep it short and to the point. 1.03. What is the ratio of the Aid flow from UN agencies (US$) in Small states in 2007 to that in 2009?
Offer a very short reply. 0.81. What is the ratio of the Aid flow from UN agencies (US$) of Sub-Saharan Africa (developing only) in 2007 to that in 2009?
Your response must be concise. 0.58. What is the ratio of the Aid flow from UN agencies (US$) of Cote d'Ivoire in 2007 to that in 2009?
Offer a terse response. 0.7. What is the ratio of the Aid flow from UN agencies (US$) of Mozambique in 2007 to that in 2009?
Your answer should be very brief. 0.83. What is the ratio of the Aid flow from UN agencies (US$) in Small states in 2007 to that in 2010?
Provide a short and direct response. 1.19. What is the ratio of the Aid flow from UN agencies (US$) in Sub-Saharan Africa (developing only) in 2007 to that in 2010?
Keep it short and to the point. 0.94. What is the ratio of the Aid flow from UN agencies (US$) in Cote d'Ivoire in 2007 to that in 2010?
Make the answer very short. 2.81. What is the ratio of the Aid flow from UN agencies (US$) in Small states in 2008 to that in 2009?
Provide a short and direct response. 0.86. What is the ratio of the Aid flow from UN agencies (US$) in Sub-Saharan Africa (developing only) in 2008 to that in 2009?
Offer a terse response. 0.74. What is the ratio of the Aid flow from UN agencies (US$) in Cote d'Ivoire in 2008 to that in 2009?
Your answer should be compact. 1.1. What is the ratio of the Aid flow from UN agencies (US$) of Mozambique in 2008 to that in 2009?
Keep it short and to the point. 0.81. What is the ratio of the Aid flow from UN agencies (US$) of Small states in 2008 to that in 2010?
Your answer should be compact. 1.26. What is the ratio of the Aid flow from UN agencies (US$) of Sub-Saharan Africa (developing only) in 2008 to that in 2010?
Your answer should be very brief. 1.2. What is the ratio of the Aid flow from UN agencies (US$) in Cote d'Ivoire in 2008 to that in 2010?
Offer a very short reply. 4.4. What is the ratio of the Aid flow from UN agencies (US$) in Mozambique in 2008 to that in 2010?
Provide a short and direct response. 1.26. What is the ratio of the Aid flow from UN agencies (US$) of Small states in 2009 to that in 2010?
Make the answer very short. 1.47. What is the ratio of the Aid flow from UN agencies (US$) of Sub-Saharan Africa (developing only) in 2009 to that in 2010?
Your answer should be compact. 1.63. What is the ratio of the Aid flow from UN agencies (US$) of Cote d'Ivoire in 2009 to that in 2010?
Give a very brief answer. 4.02. What is the ratio of the Aid flow from UN agencies (US$) in Mozambique in 2009 to that in 2010?
Your answer should be very brief. 1.56. What is the difference between the highest and the second highest Aid flow from UN agencies (US$) of Small states?
Give a very brief answer. 8.30e+05. What is the difference between the highest and the second highest Aid flow from UN agencies (US$) of Sub-Saharan Africa (developing only)?
Keep it short and to the point. 2.21e+07. What is the difference between the highest and the second highest Aid flow from UN agencies (US$) of Mozambique?
Offer a terse response. 2.10e+05. What is the difference between the highest and the lowest Aid flow from UN agencies (US$) in Small states?
Your answer should be very brief. 4.16e+06. What is the difference between the highest and the lowest Aid flow from UN agencies (US$) of Sub-Saharan Africa (developing only)?
Offer a very short reply. 6.23e+07. What is the difference between the highest and the lowest Aid flow from UN agencies (US$) of Cote d'Ivoire?
Offer a terse response. 1.77e+06. 